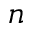<formula> <loc_0><loc_0><loc_500><loc_500>n</formula> 